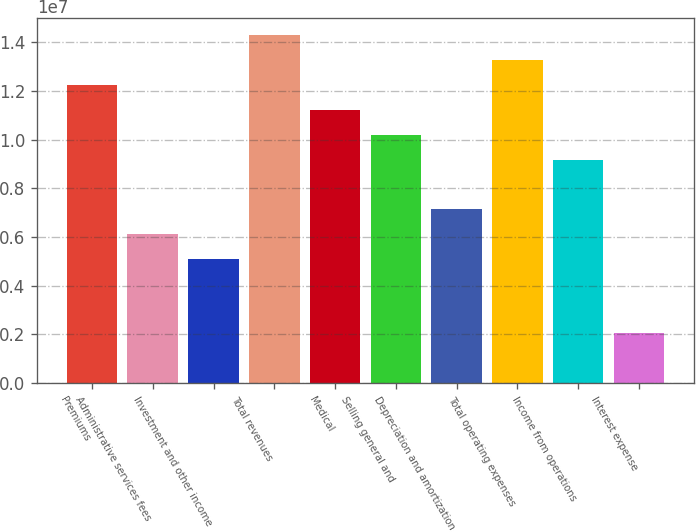Convert chart. <chart><loc_0><loc_0><loc_500><loc_500><bar_chart><fcel>Premiums<fcel>Administrative services fees<fcel>Investment and other income<fcel>Total revenues<fcel>Medical<fcel>Selling general and<fcel>Depreciation and amortization<fcel>Total operating expenses<fcel>Income from operations<fcel>Interest expense<nl><fcel>1.22339e+07<fcel>6.11693e+06<fcel>5.09744e+06<fcel>1.42728e+07<fcel>1.12144e+07<fcel>1.01949e+07<fcel>7.13642e+06<fcel>1.32534e+07<fcel>9.1754e+06<fcel>2.03898e+06<nl></chart> 